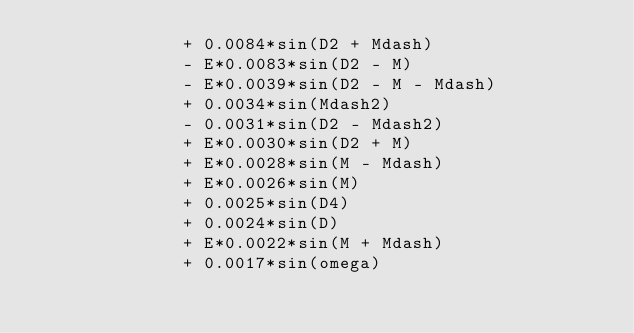Convert code to text. <code><loc_0><loc_0><loc_500><loc_500><_C++_>              + 0.0084*sin(D2 + Mdash) 
              - E*0.0083*sin(D2 - M) 
              - E*0.0039*sin(D2 - M - Mdash) 
              + 0.0034*sin(Mdash2) 
              - 0.0031*sin(D2 - Mdash2) 
              + E*0.0030*sin(D2 + M) 
              + E*0.0028*sin(M - Mdash) 
              + E*0.0026*sin(M) 
              + 0.0025*sin(D4) 
              + 0.0024*sin(D) 
              + E*0.0022*sin(M + Mdash) 
              + 0.0017*sin(omega) </code> 